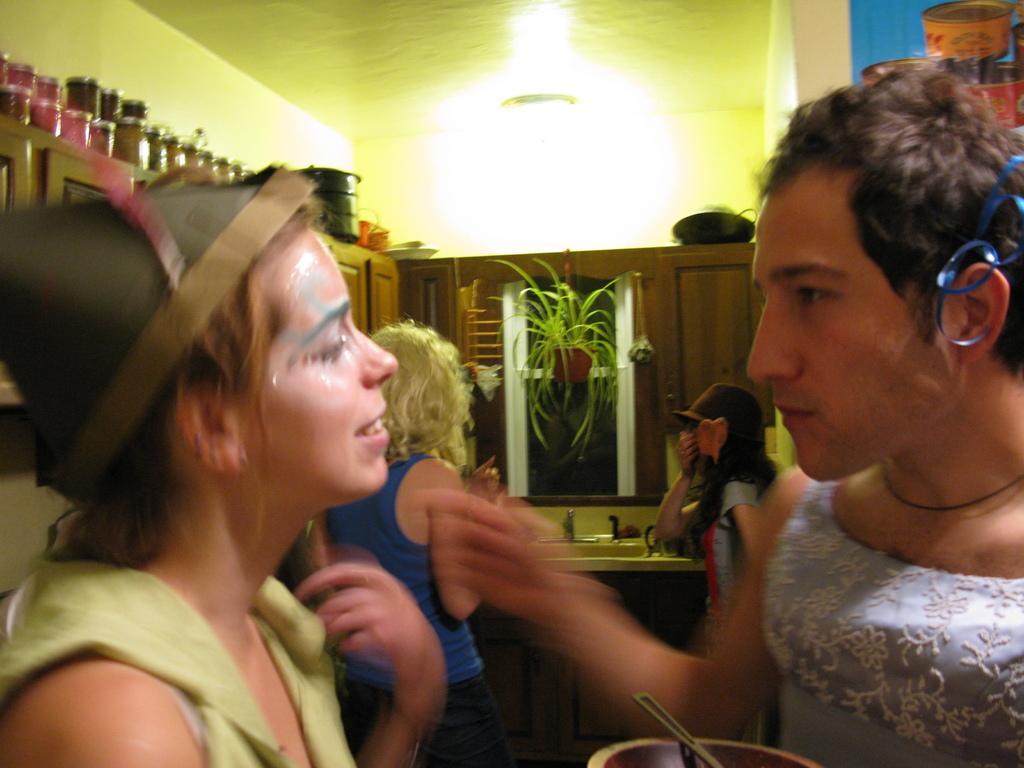In one or two sentences, can you explain what this image depicts? In this picture we can see four people, houseplant, sink, tap, cupboards, jars, ceiling, poster, walls and some objects. 